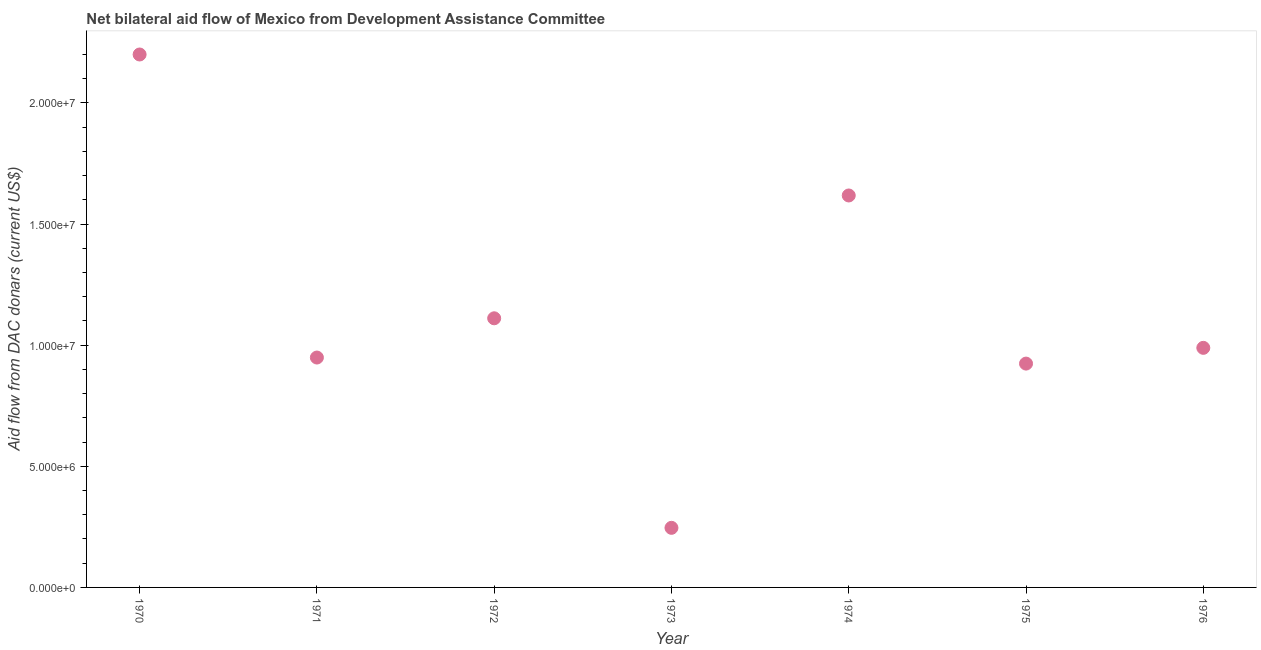What is the net bilateral aid flows from dac donors in 1970?
Provide a succinct answer. 2.20e+07. Across all years, what is the maximum net bilateral aid flows from dac donors?
Offer a terse response. 2.20e+07. Across all years, what is the minimum net bilateral aid flows from dac donors?
Your answer should be very brief. 2.46e+06. In which year was the net bilateral aid flows from dac donors maximum?
Ensure brevity in your answer.  1970. What is the sum of the net bilateral aid flows from dac donors?
Your response must be concise. 8.04e+07. What is the difference between the net bilateral aid flows from dac donors in 1975 and 1976?
Provide a succinct answer. -6.50e+05. What is the average net bilateral aid flows from dac donors per year?
Your response must be concise. 1.15e+07. What is the median net bilateral aid flows from dac donors?
Make the answer very short. 9.89e+06. In how many years, is the net bilateral aid flows from dac donors greater than 7000000 US$?
Provide a succinct answer. 6. What is the ratio of the net bilateral aid flows from dac donors in 1972 to that in 1975?
Ensure brevity in your answer.  1.2. What is the difference between the highest and the second highest net bilateral aid flows from dac donors?
Provide a succinct answer. 5.82e+06. What is the difference between the highest and the lowest net bilateral aid flows from dac donors?
Provide a succinct answer. 1.95e+07. How many dotlines are there?
Give a very brief answer. 1. Does the graph contain any zero values?
Provide a short and direct response. No. Does the graph contain grids?
Offer a very short reply. No. What is the title of the graph?
Your answer should be very brief. Net bilateral aid flow of Mexico from Development Assistance Committee. What is the label or title of the X-axis?
Offer a very short reply. Year. What is the label or title of the Y-axis?
Offer a very short reply. Aid flow from DAC donars (current US$). What is the Aid flow from DAC donars (current US$) in 1970?
Make the answer very short. 2.20e+07. What is the Aid flow from DAC donars (current US$) in 1971?
Your response must be concise. 9.49e+06. What is the Aid flow from DAC donars (current US$) in 1972?
Give a very brief answer. 1.11e+07. What is the Aid flow from DAC donars (current US$) in 1973?
Ensure brevity in your answer.  2.46e+06. What is the Aid flow from DAC donars (current US$) in 1974?
Keep it short and to the point. 1.62e+07. What is the Aid flow from DAC donars (current US$) in 1975?
Provide a succinct answer. 9.24e+06. What is the Aid flow from DAC donars (current US$) in 1976?
Keep it short and to the point. 9.89e+06. What is the difference between the Aid flow from DAC donars (current US$) in 1970 and 1971?
Provide a succinct answer. 1.25e+07. What is the difference between the Aid flow from DAC donars (current US$) in 1970 and 1972?
Offer a terse response. 1.09e+07. What is the difference between the Aid flow from DAC donars (current US$) in 1970 and 1973?
Offer a terse response. 1.95e+07. What is the difference between the Aid flow from DAC donars (current US$) in 1970 and 1974?
Offer a terse response. 5.82e+06. What is the difference between the Aid flow from DAC donars (current US$) in 1970 and 1975?
Offer a terse response. 1.28e+07. What is the difference between the Aid flow from DAC donars (current US$) in 1970 and 1976?
Provide a succinct answer. 1.21e+07. What is the difference between the Aid flow from DAC donars (current US$) in 1971 and 1972?
Your answer should be very brief. -1.62e+06. What is the difference between the Aid flow from DAC donars (current US$) in 1971 and 1973?
Make the answer very short. 7.03e+06. What is the difference between the Aid flow from DAC donars (current US$) in 1971 and 1974?
Provide a short and direct response. -6.69e+06. What is the difference between the Aid flow from DAC donars (current US$) in 1971 and 1975?
Your answer should be very brief. 2.50e+05. What is the difference between the Aid flow from DAC donars (current US$) in 1971 and 1976?
Ensure brevity in your answer.  -4.00e+05. What is the difference between the Aid flow from DAC donars (current US$) in 1972 and 1973?
Ensure brevity in your answer.  8.65e+06. What is the difference between the Aid flow from DAC donars (current US$) in 1972 and 1974?
Provide a short and direct response. -5.07e+06. What is the difference between the Aid flow from DAC donars (current US$) in 1972 and 1975?
Your response must be concise. 1.87e+06. What is the difference between the Aid flow from DAC donars (current US$) in 1972 and 1976?
Give a very brief answer. 1.22e+06. What is the difference between the Aid flow from DAC donars (current US$) in 1973 and 1974?
Your answer should be compact. -1.37e+07. What is the difference between the Aid flow from DAC donars (current US$) in 1973 and 1975?
Make the answer very short. -6.78e+06. What is the difference between the Aid flow from DAC donars (current US$) in 1973 and 1976?
Provide a succinct answer. -7.43e+06. What is the difference between the Aid flow from DAC donars (current US$) in 1974 and 1975?
Your answer should be compact. 6.94e+06. What is the difference between the Aid flow from DAC donars (current US$) in 1974 and 1976?
Give a very brief answer. 6.29e+06. What is the difference between the Aid flow from DAC donars (current US$) in 1975 and 1976?
Your answer should be compact. -6.50e+05. What is the ratio of the Aid flow from DAC donars (current US$) in 1970 to that in 1971?
Keep it short and to the point. 2.32. What is the ratio of the Aid flow from DAC donars (current US$) in 1970 to that in 1972?
Ensure brevity in your answer.  1.98. What is the ratio of the Aid flow from DAC donars (current US$) in 1970 to that in 1973?
Your answer should be very brief. 8.94. What is the ratio of the Aid flow from DAC donars (current US$) in 1970 to that in 1974?
Ensure brevity in your answer.  1.36. What is the ratio of the Aid flow from DAC donars (current US$) in 1970 to that in 1975?
Your answer should be compact. 2.38. What is the ratio of the Aid flow from DAC donars (current US$) in 1970 to that in 1976?
Your answer should be compact. 2.22. What is the ratio of the Aid flow from DAC donars (current US$) in 1971 to that in 1972?
Provide a succinct answer. 0.85. What is the ratio of the Aid flow from DAC donars (current US$) in 1971 to that in 1973?
Offer a very short reply. 3.86. What is the ratio of the Aid flow from DAC donars (current US$) in 1971 to that in 1974?
Keep it short and to the point. 0.59. What is the ratio of the Aid flow from DAC donars (current US$) in 1971 to that in 1975?
Offer a very short reply. 1.03. What is the ratio of the Aid flow from DAC donars (current US$) in 1971 to that in 1976?
Offer a terse response. 0.96. What is the ratio of the Aid flow from DAC donars (current US$) in 1972 to that in 1973?
Provide a short and direct response. 4.52. What is the ratio of the Aid flow from DAC donars (current US$) in 1972 to that in 1974?
Make the answer very short. 0.69. What is the ratio of the Aid flow from DAC donars (current US$) in 1972 to that in 1975?
Provide a succinct answer. 1.2. What is the ratio of the Aid flow from DAC donars (current US$) in 1972 to that in 1976?
Provide a succinct answer. 1.12. What is the ratio of the Aid flow from DAC donars (current US$) in 1973 to that in 1974?
Your answer should be compact. 0.15. What is the ratio of the Aid flow from DAC donars (current US$) in 1973 to that in 1975?
Keep it short and to the point. 0.27. What is the ratio of the Aid flow from DAC donars (current US$) in 1973 to that in 1976?
Offer a terse response. 0.25. What is the ratio of the Aid flow from DAC donars (current US$) in 1974 to that in 1975?
Your response must be concise. 1.75. What is the ratio of the Aid flow from DAC donars (current US$) in 1974 to that in 1976?
Your answer should be compact. 1.64. What is the ratio of the Aid flow from DAC donars (current US$) in 1975 to that in 1976?
Your answer should be compact. 0.93. 